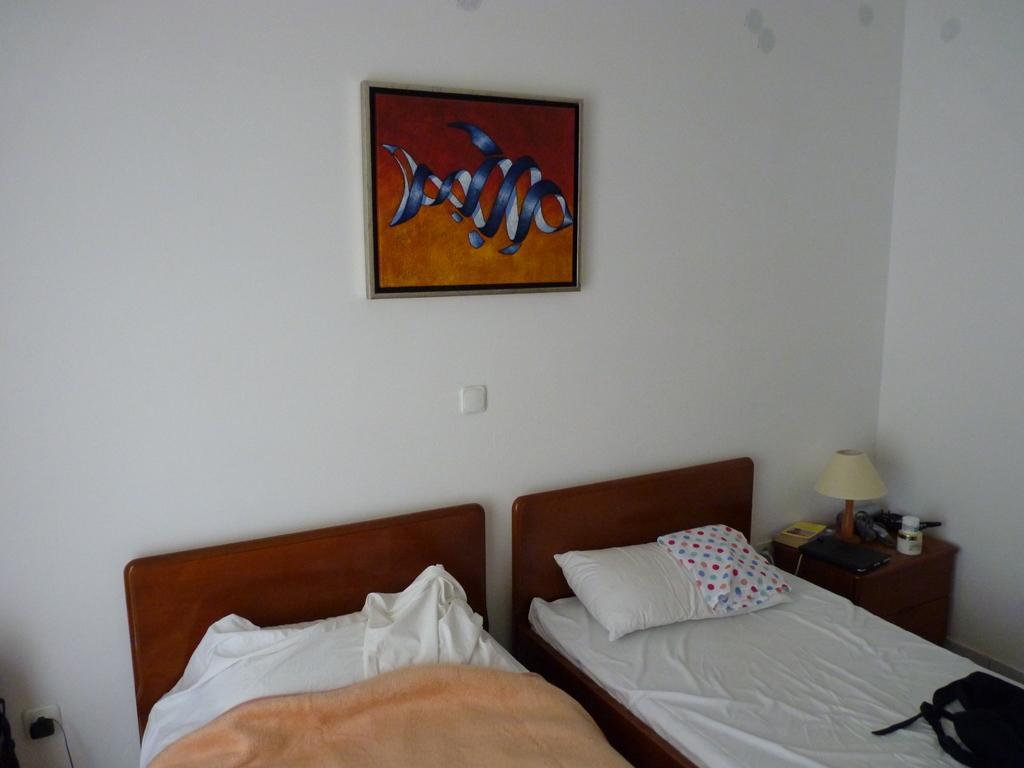Could you give a brief overview of what you see in this image? In this picture we can see beds. This is pillow. On the background there is a wall and this is frame. Here we can see a lamp on the table. 